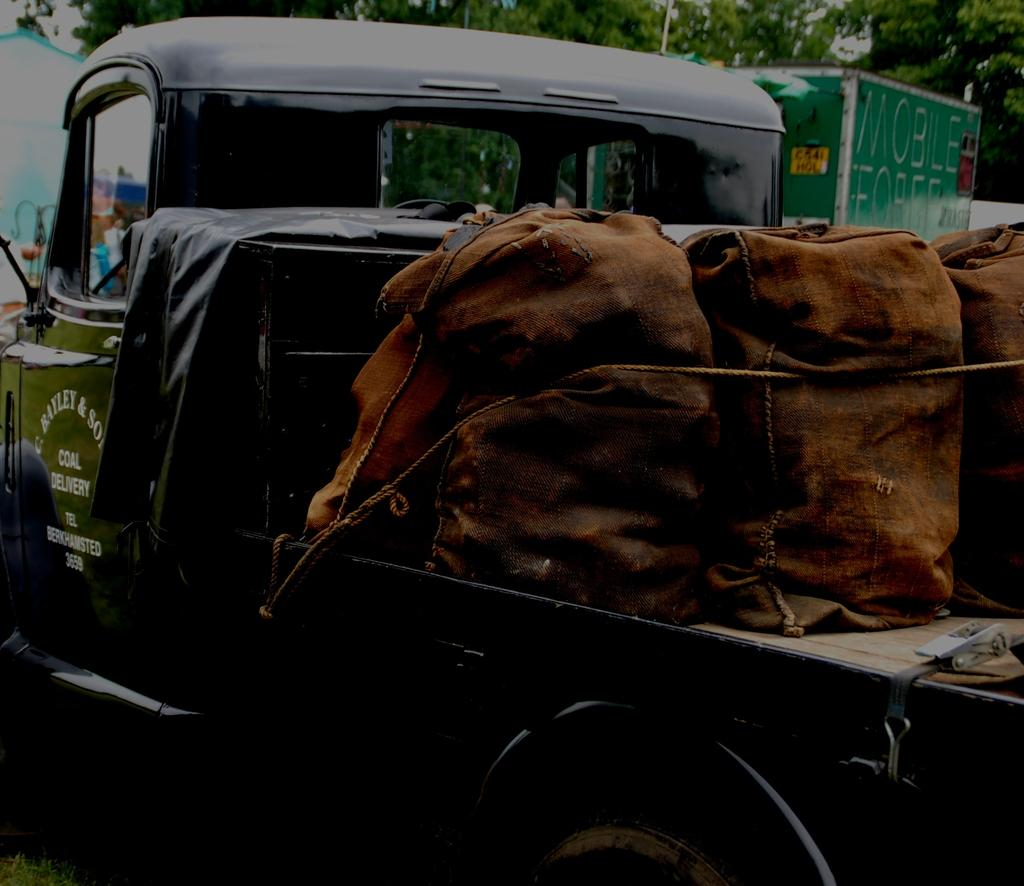What is the main subject of the image? The main subject of the image is a truck. What is on the truck? The truck has bags on it. Is there anything else connected to the truck? Yes, there is a rope tied to the truck. What can be seen in the background of the image? There are trees and a green color board in the background of the image. How does the stranger interact with the truck in the image? There is no stranger present in the image, so it is not possible to determine how they might interact with the truck. 